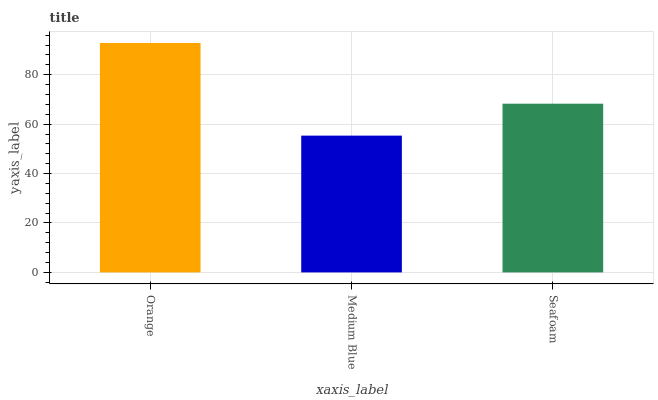Is Medium Blue the minimum?
Answer yes or no. Yes. Is Orange the maximum?
Answer yes or no. Yes. Is Seafoam the minimum?
Answer yes or no. No. Is Seafoam the maximum?
Answer yes or no. No. Is Seafoam greater than Medium Blue?
Answer yes or no. Yes. Is Medium Blue less than Seafoam?
Answer yes or no. Yes. Is Medium Blue greater than Seafoam?
Answer yes or no. No. Is Seafoam less than Medium Blue?
Answer yes or no. No. Is Seafoam the high median?
Answer yes or no. Yes. Is Seafoam the low median?
Answer yes or no. Yes. Is Medium Blue the high median?
Answer yes or no. No. Is Orange the low median?
Answer yes or no. No. 